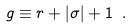Convert formula to latex. <formula><loc_0><loc_0><loc_500><loc_500>g \equiv r + | \sigma | + 1 \ .</formula> 